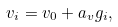<formula> <loc_0><loc_0><loc_500><loc_500>v _ { i } = v _ { 0 } + a _ { v } g _ { i } ,</formula> 